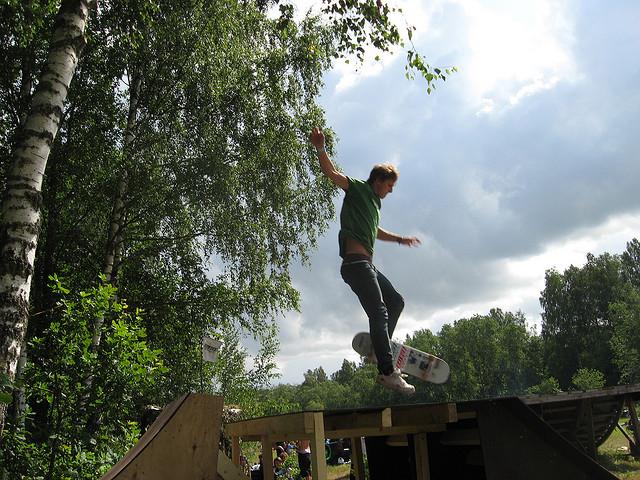Is this an overcast day?
Be succinct. Yes. Are the ramps connected?
Quick response, please. No. Is the person falling?
Answer briefly. Yes. What is the material of the platform?
Keep it brief. Wood. 